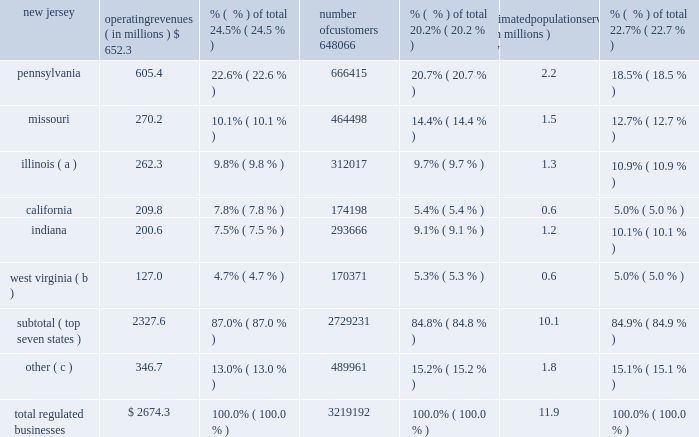Part i item 1 .
Business our company founded in 1886 , american water works company , inc. , ( the 201ccompany , 201d 201camerican water 201d or 201caww 201d ) is a delaware holding company .
American water is the most geographically diversified , as well as the largest publicly-traded , united states water and wastewater utility company , as measured by both operating revenues and population served .
As a holding company , we conduct substantially all of our business operations through our subsidiaries .
Our approximately 6400 employees provide an estimated 15 million people with drinking water , wastewater and/or other water-related services in 47 states and one canadian province .
Operating segments we report our results of operations in two operating segments : the regulated businesses and the market- based operations .
Additional information with respect to our operating segment results is included in the section entitled 201citem 7 2014management 2019s discussion and analysis of financial condition and results of operations , 201d and note 18 of the consolidated financial statements .
Regulated businesses our primary business involves the ownership of subsidiaries that provide water and wastewater utility services to residential , commercial , industrial and other customers , including sale for resale and public authority customers .
We report the results of this business in our regulated businesses segment .
Our subsidiaries that provide these services are generally subject to economic regulation by certain state commissions or other entities engaged in economic regulation , hereafter referred to as public utility commissions , or 201cpucs , 201d of the states in which we operate .
The federal and state governments also regulate environmental , health and safety , and water quality matters .
Our regulated businesses segment operating revenues were $ 2674.3 million for 2014 , $ 2539.9 for 2013 , $ 2564.4 million for 2012 , accounting for 88.8% ( 88.8 % ) , 90.1% ( 90.1 % ) and 89.9% ( 89.9 % ) , respectively , of total operating revenues for the same periods .
The table sets forth our regulated businesses operating revenues , number of customers and an estimate of population served as of december 31 , 2014 : operating revenues ( in millions ) % (  % ) of total number of customers % (  % ) of total estimated population served ( in millions ) % (  % ) of total .
( a ) includes illinois-american water company , which we refer to as ilawc and american lake water company , also a regulated subsidiary in illinois. .
What is approximate customer penetration percentage in the total regulated businesses? 
Computations: (3219192 / (11.9 * 1000000))
Answer: 0.27052. 